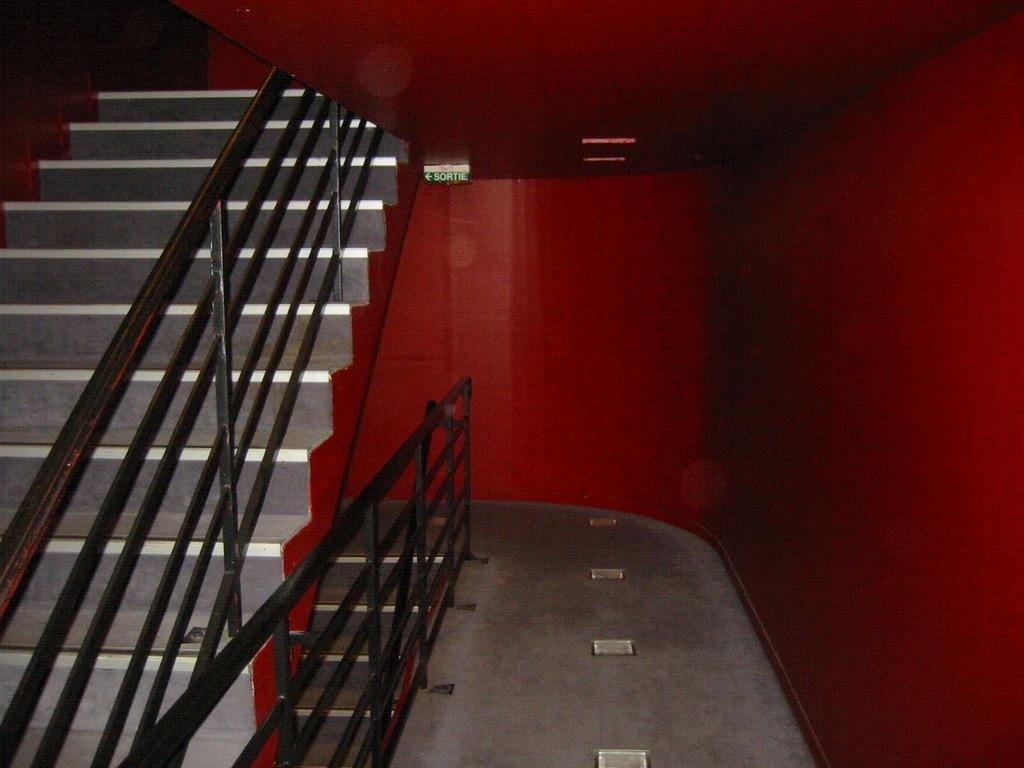What type of structure is present in the image? There is a staircase in the image. What feature is present on the staircase for safety? There is a steel railing on the staircase. What else can be seen in the image besides the staircase? There is a wall in the image. What color is the wall in the image? The wall is painted red. How much money is scattered on the stairs in the image? There is no money scattered on the stairs in the image. What type of cream is being used to paint the wall in the image? The wall is painted red, and there is no mention of cream being used in the image. 